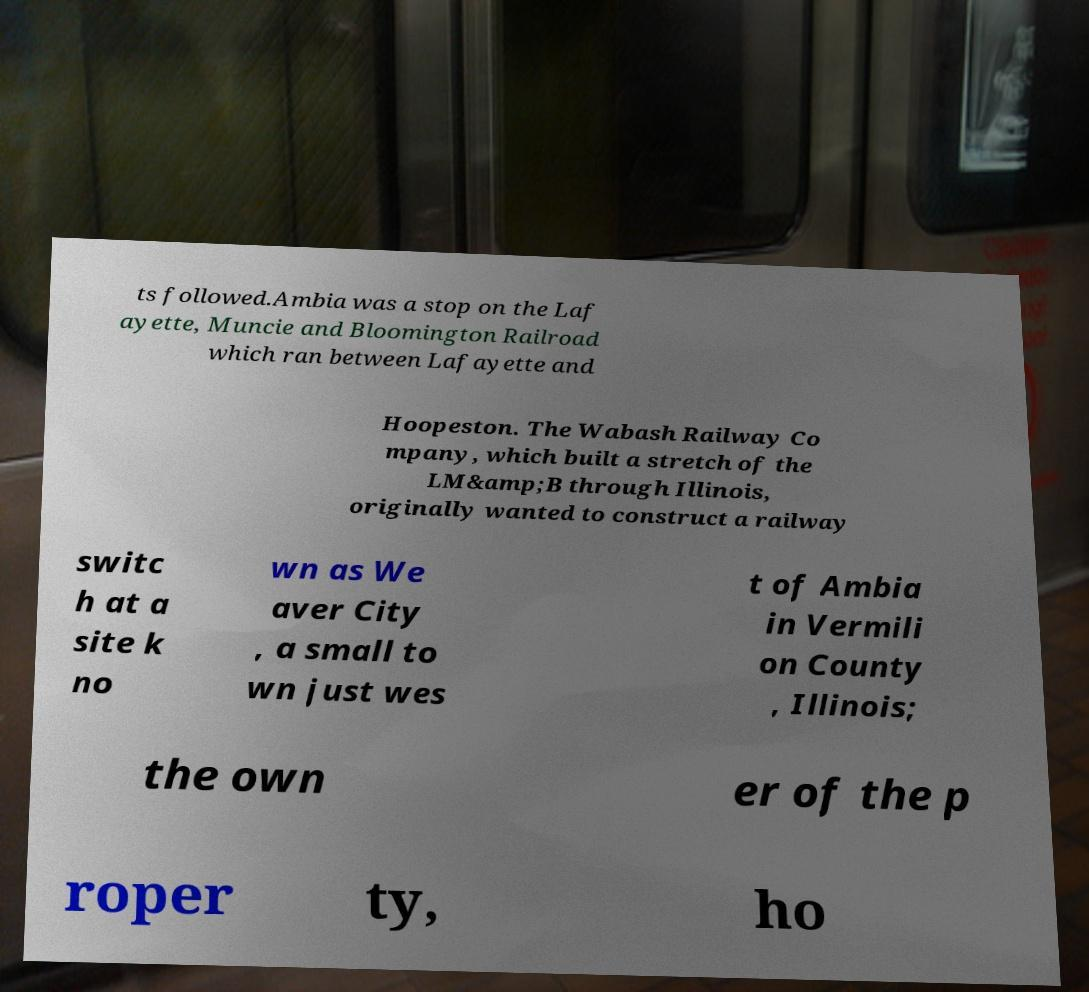For documentation purposes, I need the text within this image transcribed. Could you provide that? ts followed.Ambia was a stop on the Laf ayette, Muncie and Bloomington Railroad which ran between Lafayette and Hoopeston. The Wabash Railway Co mpany, which built a stretch of the LM&amp;B through Illinois, originally wanted to construct a railway switc h at a site k no wn as We aver City , a small to wn just wes t of Ambia in Vermili on County , Illinois; the own er of the p roper ty, ho 